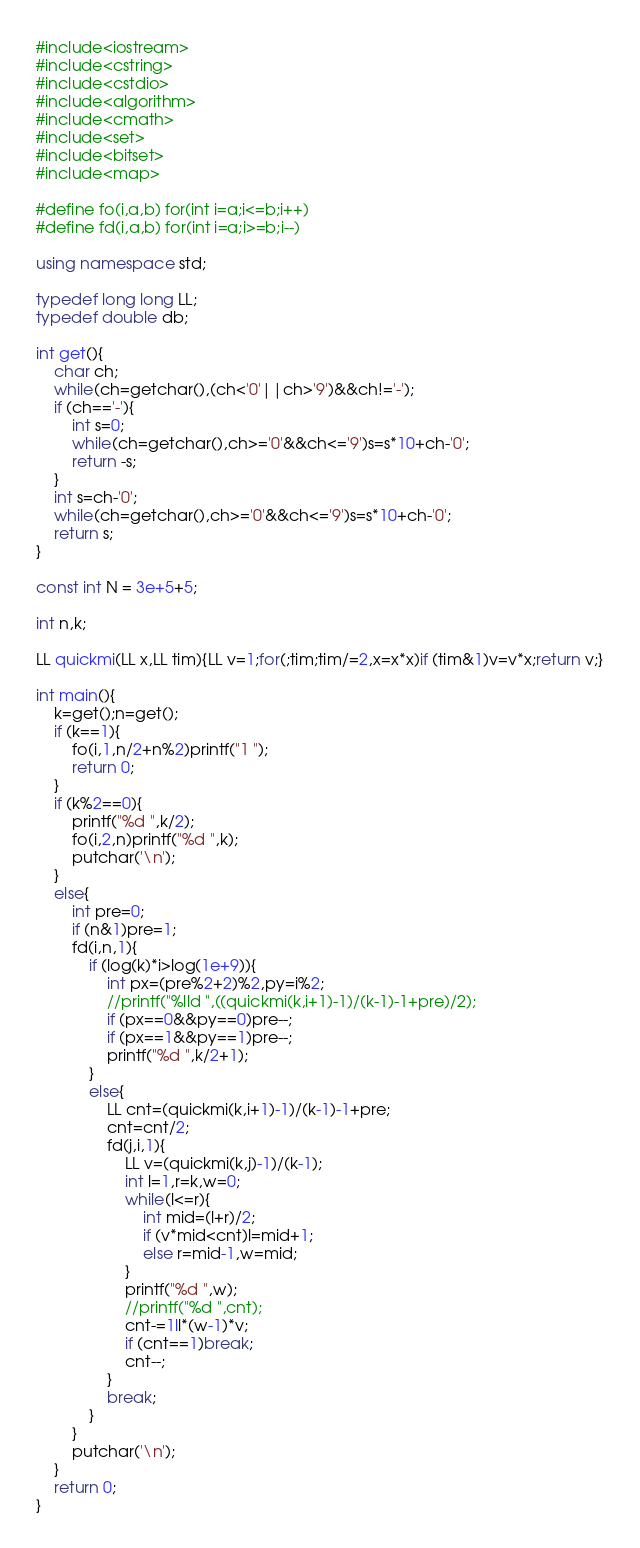<code> <loc_0><loc_0><loc_500><loc_500><_C++_>#include<iostream>
#include<cstring>
#include<cstdio>
#include<algorithm>
#include<cmath>
#include<set>
#include<bitset>
#include<map>

#define fo(i,a,b) for(int i=a;i<=b;i++)
#define fd(i,a,b) for(int i=a;i>=b;i--)

using namespace std;

typedef long long LL;
typedef double db;

int get(){
	char ch;
	while(ch=getchar(),(ch<'0'||ch>'9')&&ch!='-');
	if (ch=='-'){
		int s=0;
		while(ch=getchar(),ch>='0'&&ch<='9')s=s*10+ch-'0';
		return -s;
	}
	int s=ch-'0';
	while(ch=getchar(),ch>='0'&&ch<='9')s=s*10+ch-'0';
	return s;
}

const int N = 3e+5+5;

int n,k;

LL quickmi(LL x,LL tim){LL v=1;for(;tim;tim/=2,x=x*x)if (tim&1)v=v*x;return v;}

int main(){
	k=get();n=get();
	if (k==1){
		fo(i,1,n/2+n%2)printf("1 ");
		return 0;
	}
	if (k%2==0){
		printf("%d ",k/2);
		fo(i,2,n)printf("%d ",k);
		putchar('\n');
	}
	else{
		int pre=0;
		if (n&1)pre=1;
		fd(i,n,1){
			if (log(k)*i>log(1e+9)){
				int px=(pre%2+2)%2,py=i%2;
				//printf("%lld ",((quickmi(k,i+1)-1)/(k-1)-1+pre)/2);
				if (px==0&&py==0)pre--;
				if (px==1&&py==1)pre--;
				printf("%d ",k/2+1);
			}
			else{
				LL cnt=(quickmi(k,i+1)-1)/(k-1)-1+pre;
				cnt=cnt/2;
				fd(j,i,1){
					LL v=(quickmi(k,j)-1)/(k-1);
					int l=1,r=k,w=0;
					while(l<=r){
						int mid=(l+r)/2;
						if (v*mid<cnt)l=mid+1;
						else r=mid-1,w=mid;
					}
					printf("%d ",w);
					//printf("%d ",cnt);
					cnt-=1ll*(w-1)*v;
					if (cnt==1)break;
					cnt--;
				}
				break;
			}
		}
		putchar('\n');
	}
	return 0;
}</code> 